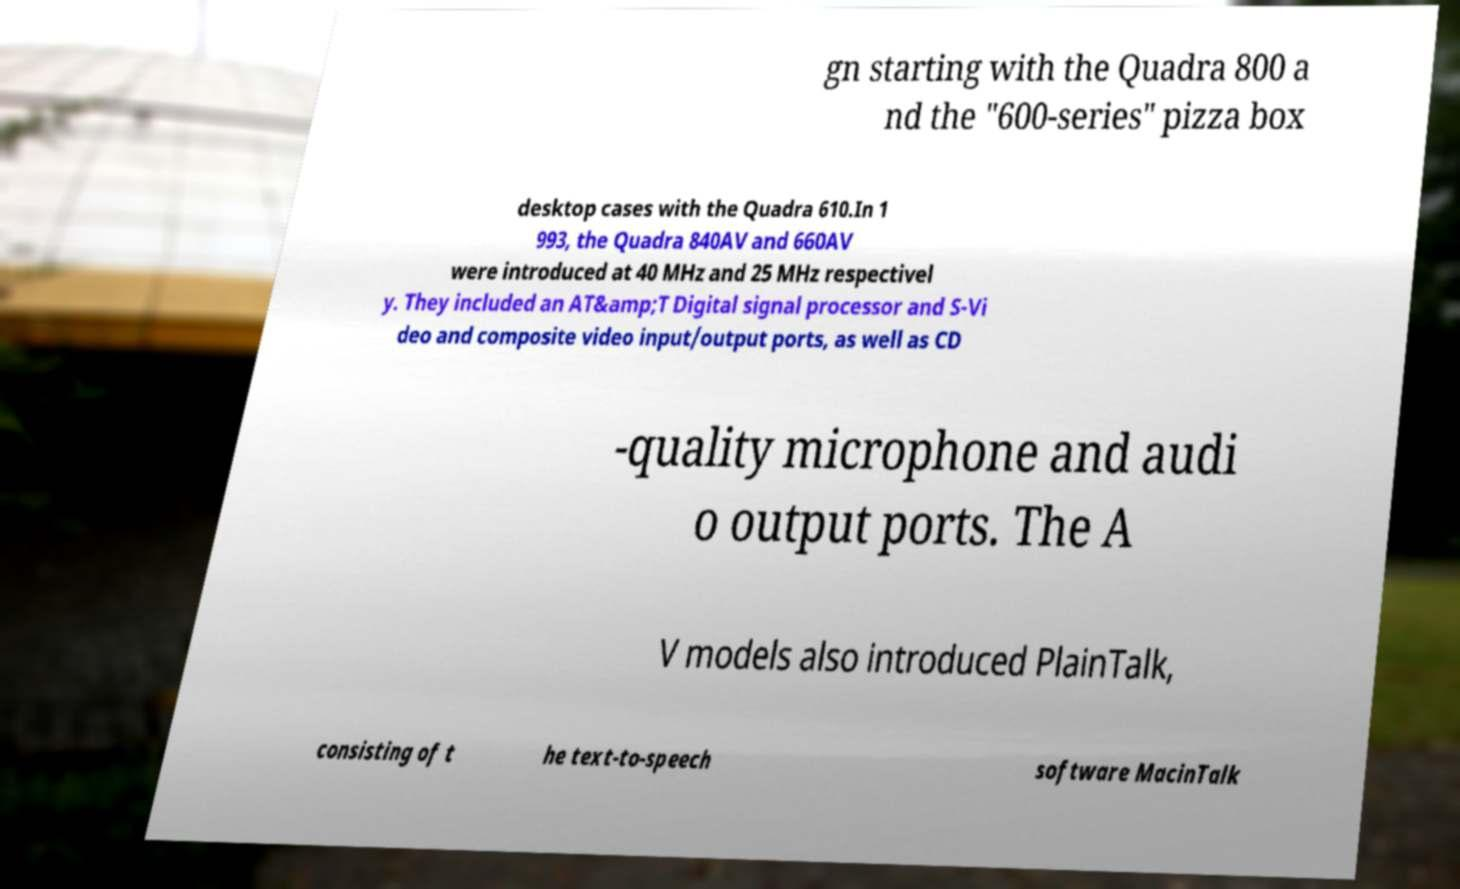Could you extract and type out the text from this image? gn starting with the Quadra 800 a nd the "600-series" pizza box desktop cases with the Quadra 610.In 1 993, the Quadra 840AV and 660AV were introduced at 40 MHz and 25 MHz respectivel y. They included an AT&amp;T Digital signal processor and S-Vi deo and composite video input/output ports, as well as CD -quality microphone and audi o output ports. The A V models also introduced PlainTalk, consisting of t he text-to-speech software MacinTalk 